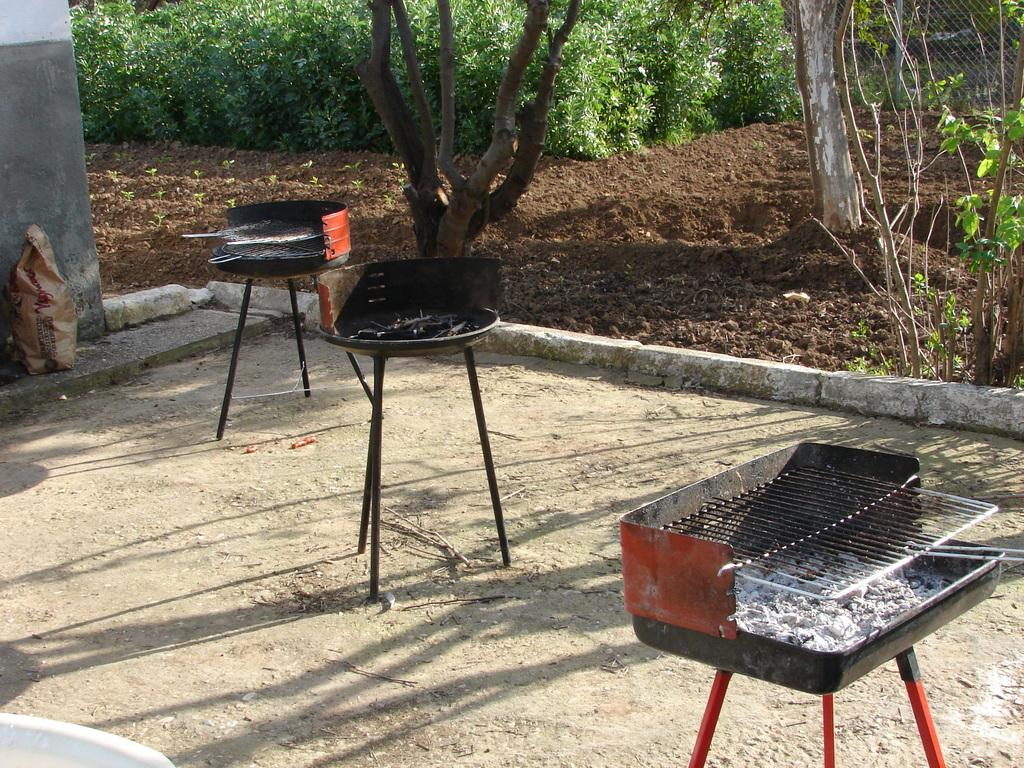How many outdoor barbecue grill racks are visible in the image? There are three outdoor barbecue grill racks on the ground in the image. What is the surface behind the grill racks? There is a soil surface behind the grill racks. What type of vegetation can be seen in the image? There are trees and plants in the image. What type of fiction is being read by the string hanging from the board in the image? There is no board, string, or fiction present in the image; it only features outdoor barbecue grill racks, a soil surface, trees, and plants. 